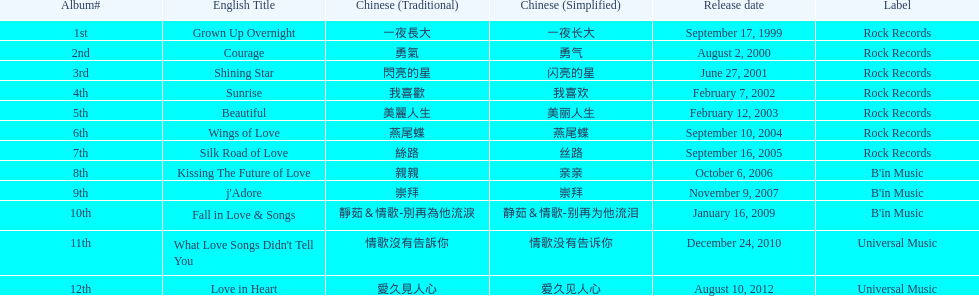Can you list the songs that were part of b'in music or universal music? Kissing The Future of Love, j'Adore, Fall in Love & Songs, What Love Songs Didn't Tell You, Love in Heart. 